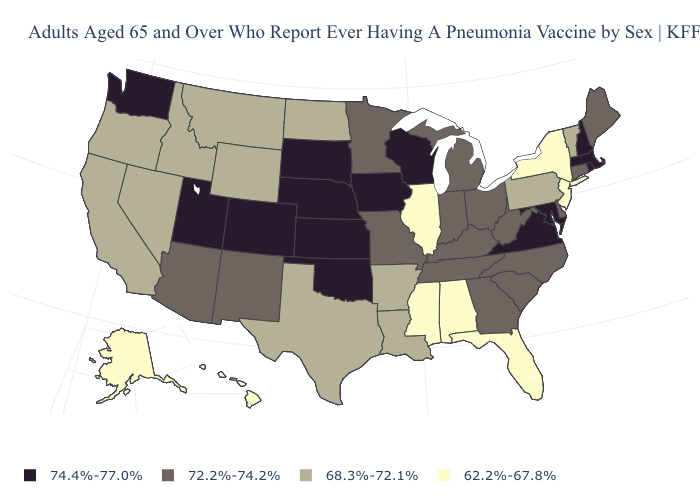What is the lowest value in the MidWest?
Answer briefly. 62.2%-67.8%. Name the states that have a value in the range 74.4%-77.0%?
Short answer required. Colorado, Iowa, Kansas, Maryland, Massachusetts, Nebraska, New Hampshire, Oklahoma, Rhode Island, South Dakota, Utah, Virginia, Washington, Wisconsin. Name the states that have a value in the range 62.2%-67.8%?
Quick response, please. Alabama, Alaska, Florida, Hawaii, Illinois, Mississippi, New Jersey, New York. Name the states that have a value in the range 62.2%-67.8%?
Give a very brief answer. Alabama, Alaska, Florida, Hawaii, Illinois, Mississippi, New Jersey, New York. Does Washington have a higher value than Georgia?
Give a very brief answer. Yes. What is the value of New York?
Be succinct. 62.2%-67.8%. Which states have the highest value in the USA?
Be succinct. Colorado, Iowa, Kansas, Maryland, Massachusetts, Nebraska, New Hampshire, Oklahoma, Rhode Island, South Dakota, Utah, Virginia, Washington, Wisconsin. What is the highest value in the South ?
Short answer required. 74.4%-77.0%. Does the map have missing data?
Keep it brief. No. Which states have the lowest value in the USA?
Answer briefly. Alabama, Alaska, Florida, Hawaii, Illinois, Mississippi, New Jersey, New York. What is the value of Nevada?
Be succinct. 68.3%-72.1%. What is the value of Kansas?
Answer briefly. 74.4%-77.0%. What is the value of Illinois?
Write a very short answer. 62.2%-67.8%. Does Nevada have a higher value than Mississippi?
Keep it brief. Yes. What is the value of Maine?
Quick response, please. 72.2%-74.2%. 